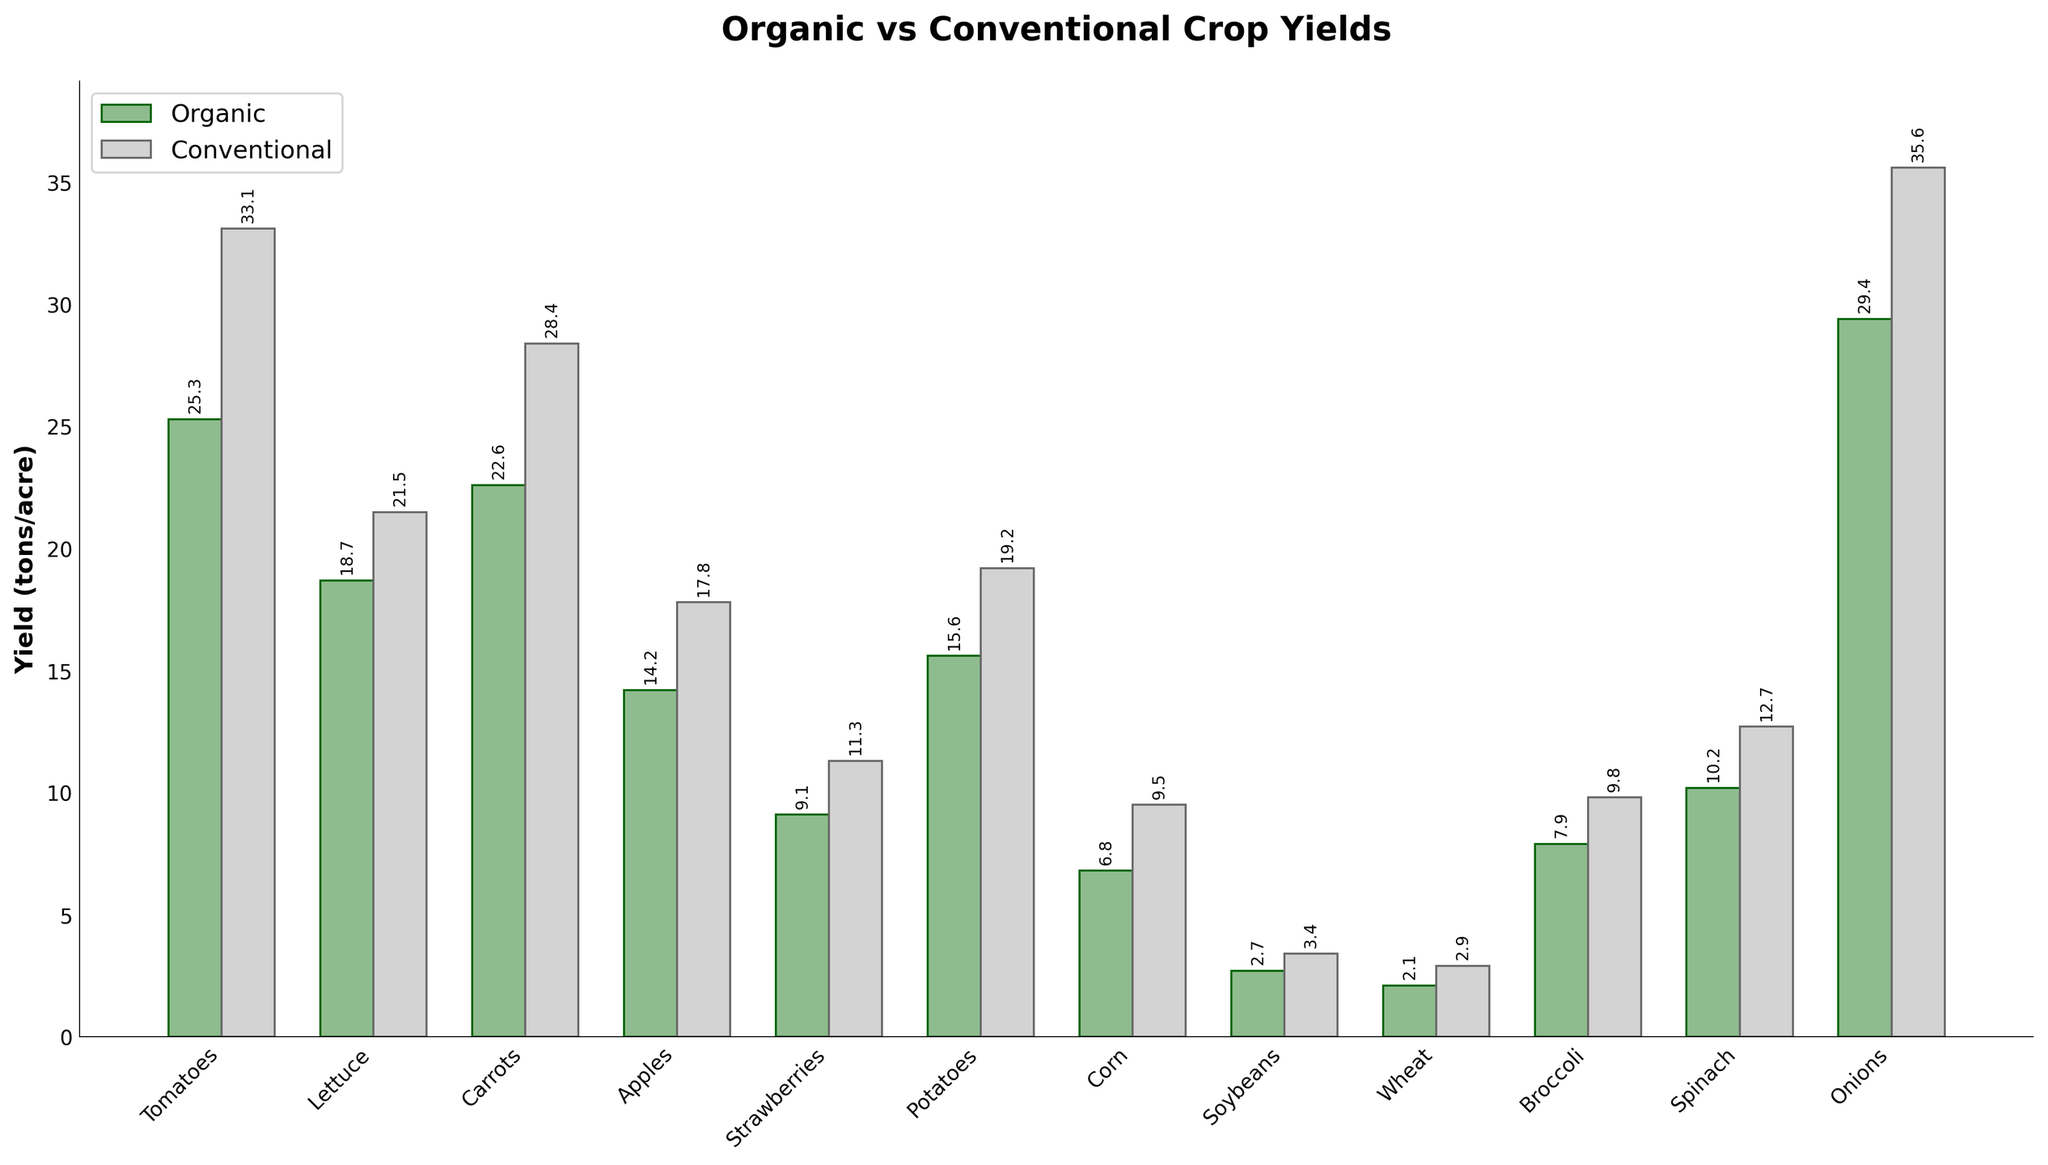Which crop has the highest conventional yield? By looking at the bar that represents conventional yields, the crop with the tallest bar is the one with the highest yield. The bar representing onions is the tallest for conventional yields.
Answer: Onions What is the difference in yield between conventional and organic tomatoes? Find the heights of the bars for conventional and organic tomatoes and subtract the organic yield from the conventional yield. The yields are 33.1 for conventional and 25.3 for organic, so 33.1 - 25.3.
Answer: 7.8 tons/acre Which crops have higher organic yields than 20 tons/acre? Identify the bars that represent organic yields above the 20 tons/acre mark. The bars for carrots (22.6), onions (29.4), and tomatoes (25.3) are above this value.
Answer: Carrots, Onions, Tomatoes For which crop is the difference between organic and conventional yields the smallest? Measure the difference between the conventional and organic yields for each crop by subtracting the organic yield from the conventional yield. Find the crop with the smallest result. For soybeans, the difference is 3.4 - 2.7 = 0.7, which is the smallest difference.
Answer: Soybeans What is the average organic yield for all crops? Add up the organic yields for all crops and divide by the number of crops. Sum of organic yields: 25.3 + 18.7 + 22.6 + 14.2 + 9.1 + 15.6 + 6.8 + 2.7 + 2.1 + 7.9 + 10.2 + 29.4 = 164.6. Number of crops: 12. Average yield = 164.6 / 12.
Answer: 13.7 tons/acre Compare the yields between organic and conventional crops for apples. Look at the bars representing the yield for apples in both organic and conventional categories. The organic yield is 14.2, and the conventional yield is 17.8, so conventional apples yield more.
Answer: Conventional yields more Which crop shows the largest yield difference in favor of conventional farming? Calculate the difference between conventional and organic yields for each crop and identify the one with the largest positive difference. The difference is largest for onions (35.6 - 29.4 = 6.2).
Answer: Onions What percentage of the yield for conventional potatoes is the yield for organic potatoes? Divide the yield of organic potatoes by the yield of conventional potatoes and multiply by 100 to get the percentage: (15.6 / 19.2) * 100.
Answer: 81.3% What is the combined yield for organic and conventional strawberries? Add the organic and conventional yields for strawberries. Organic yield: 9.1, Conventional yield: 11.3, Combined: 9.1 + 11.3.
Answer: 20.4 tons/acre Which crop has the second lowest organic yield? Rank the organic yields in ascending order and select the second smallest value. The yields are (2.1, 2.7, 6.8, 7.9, 9.1, 10.2, 14.2, 15.6, 18.7, 22.6, 25.3, 29.4). The second lowest is 2.7, which corresponds to soybeans.
Answer: Soybeans 